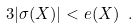Convert formula to latex. <formula><loc_0><loc_0><loc_500><loc_500>3 | \sigma ( X ) | < e ( X ) \ .</formula> 